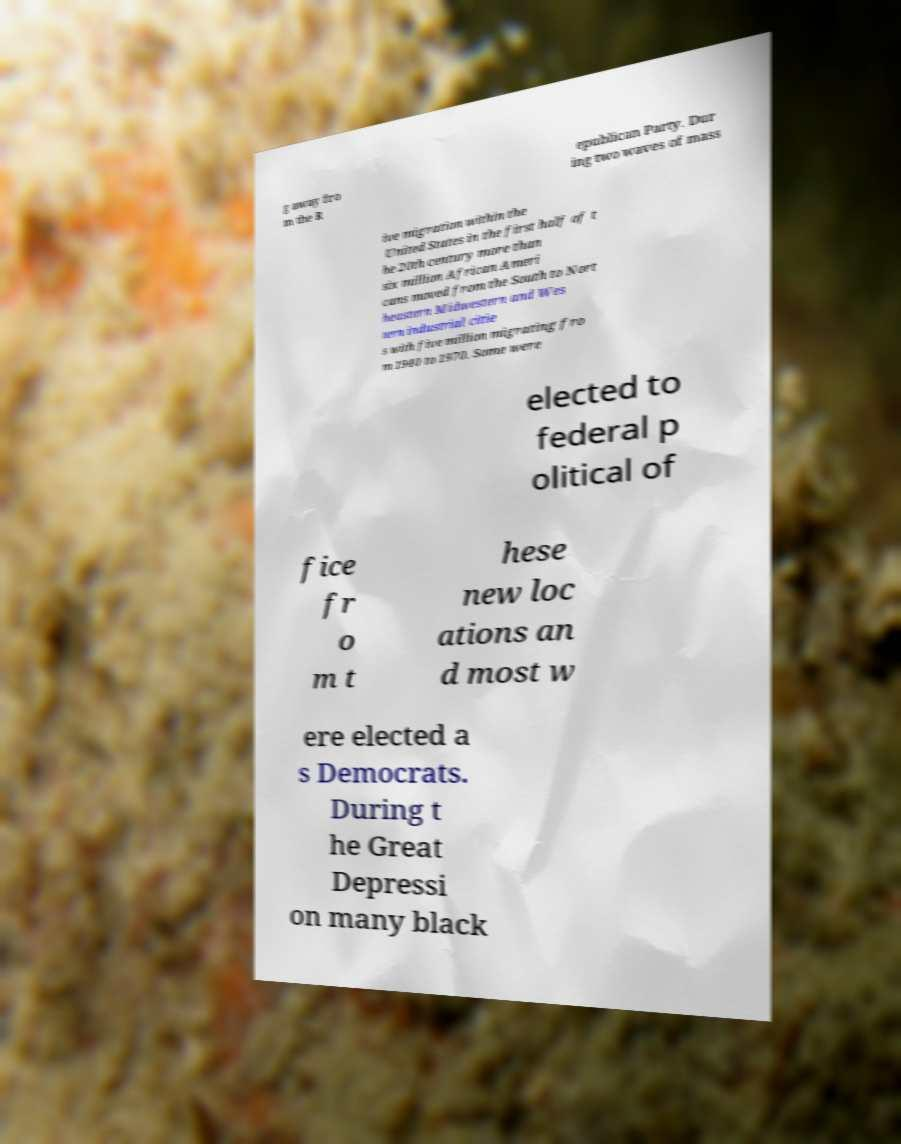Please identify and transcribe the text found in this image. g away fro m the R epublican Party. Dur ing two waves of mass ive migration within the United States in the first half of t he 20th century more than six million African Ameri cans moved from the South to Nort heastern Midwestern and Wes tern industrial citie s with five million migrating fro m 1940 to 1970. Some were elected to federal p olitical of fice fr o m t hese new loc ations an d most w ere elected a s Democrats. During t he Great Depressi on many black 